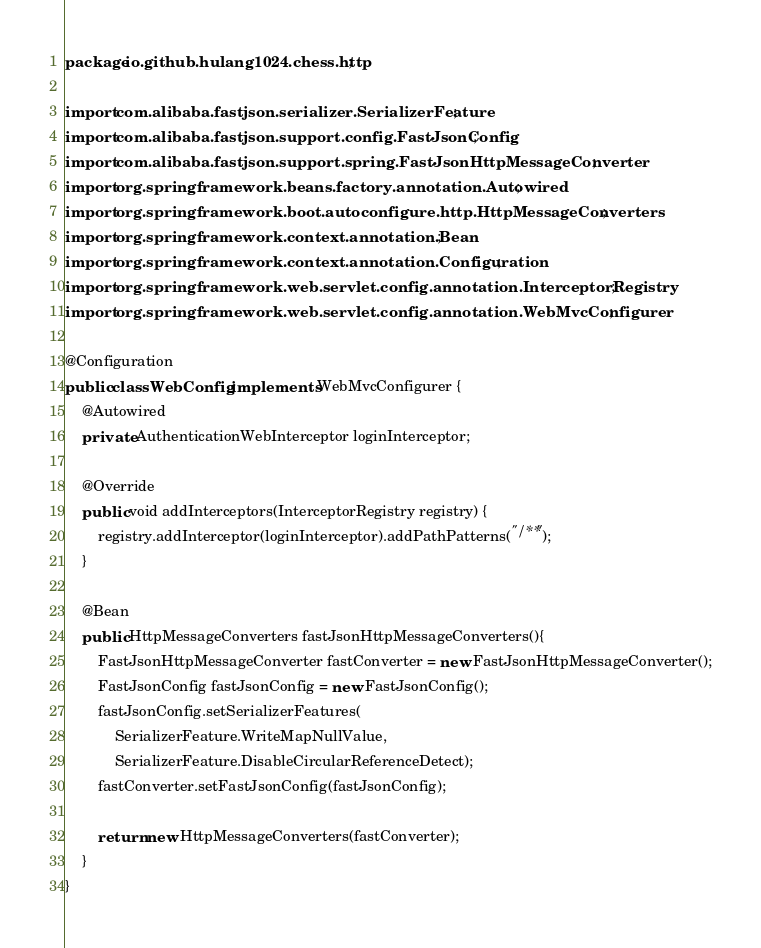Convert code to text. <code><loc_0><loc_0><loc_500><loc_500><_Java_>package io.github.hulang1024.chess.http;

import com.alibaba.fastjson.serializer.SerializerFeature;
import com.alibaba.fastjson.support.config.FastJsonConfig;
import com.alibaba.fastjson.support.spring.FastJsonHttpMessageConverter;
import org.springframework.beans.factory.annotation.Autowired;
import org.springframework.boot.autoconfigure.http.HttpMessageConverters;
import org.springframework.context.annotation.Bean;
import org.springframework.context.annotation.Configuration;
import org.springframework.web.servlet.config.annotation.InterceptorRegistry;
import org.springframework.web.servlet.config.annotation.WebMvcConfigurer;

@Configuration
public class WebConfig implements WebMvcConfigurer {
    @Autowired
    private AuthenticationWebInterceptor loginInterceptor;

    @Override
    public void addInterceptors(InterceptorRegistry registry) {
        registry.addInterceptor(loginInterceptor).addPathPatterns("/**");
    }

    @Bean
    public HttpMessageConverters fastJsonHttpMessageConverters(){
        FastJsonHttpMessageConverter fastConverter = new FastJsonHttpMessageConverter();
        FastJsonConfig fastJsonConfig = new FastJsonConfig();
        fastJsonConfig.setSerializerFeatures(
            SerializerFeature.WriteMapNullValue,
            SerializerFeature.DisableCircularReferenceDetect);
        fastConverter.setFastJsonConfig(fastJsonConfig);

        return new HttpMessageConverters(fastConverter);
    }
}</code> 